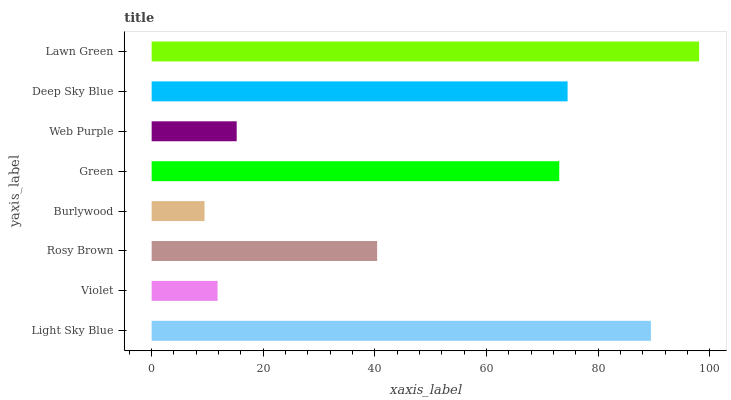Is Burlywood the minimum?
Answer yes or no. Yes. Is Lawn Green the maximum?
Answer yes or no. Yes. Is Violet the minimum?
Answer yes or no. No. Is Violet the maximum?
Answer yes or no. No. Is Light Sky Blue greater than Violet?
Answer yes or no. Yes. Is Violet less than Light Sky Blue?
Answer yes or no. Yes. Is Violet greater than Light Sky Blue?
Answer yes or no. No. Is Light Sky Blue less than Violet?
Answer yes or no. No. Is Green the high median?
Answer yes or no. Yes. Is Rosy Brown the low median?
Answer yes or no. Yes. Is Deep Sky Blue the high median?
Answer yes or no. No. Is Violet the low median?
Answer yes or no. No. 